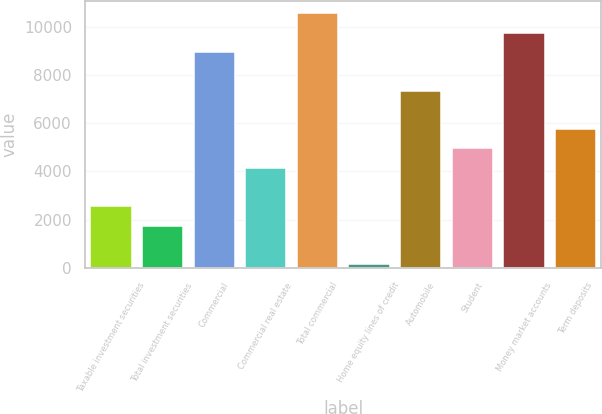<chart> <loc_0><loc_0><loc_500><loc_500><bar_chart><fcel>Taxable investment securities<fcel>Total investment securities<fcel>Commercial<fcel>Commercial real estate<fcel>Total commercial<fcel>Home equity lines of credit<fcel>Automobile<fcel>Student<fcel>Money market accounts<fcel>Term deposits<nl><fcel>2552.7<fcel>1753.8<fcel>8943.9<fcel>4150.5<fcel>10541.7<fcel>156<fcel>7346.1<fcel>4949.4<fcel>9742.8<fcel>5748.3<nl></chart> 